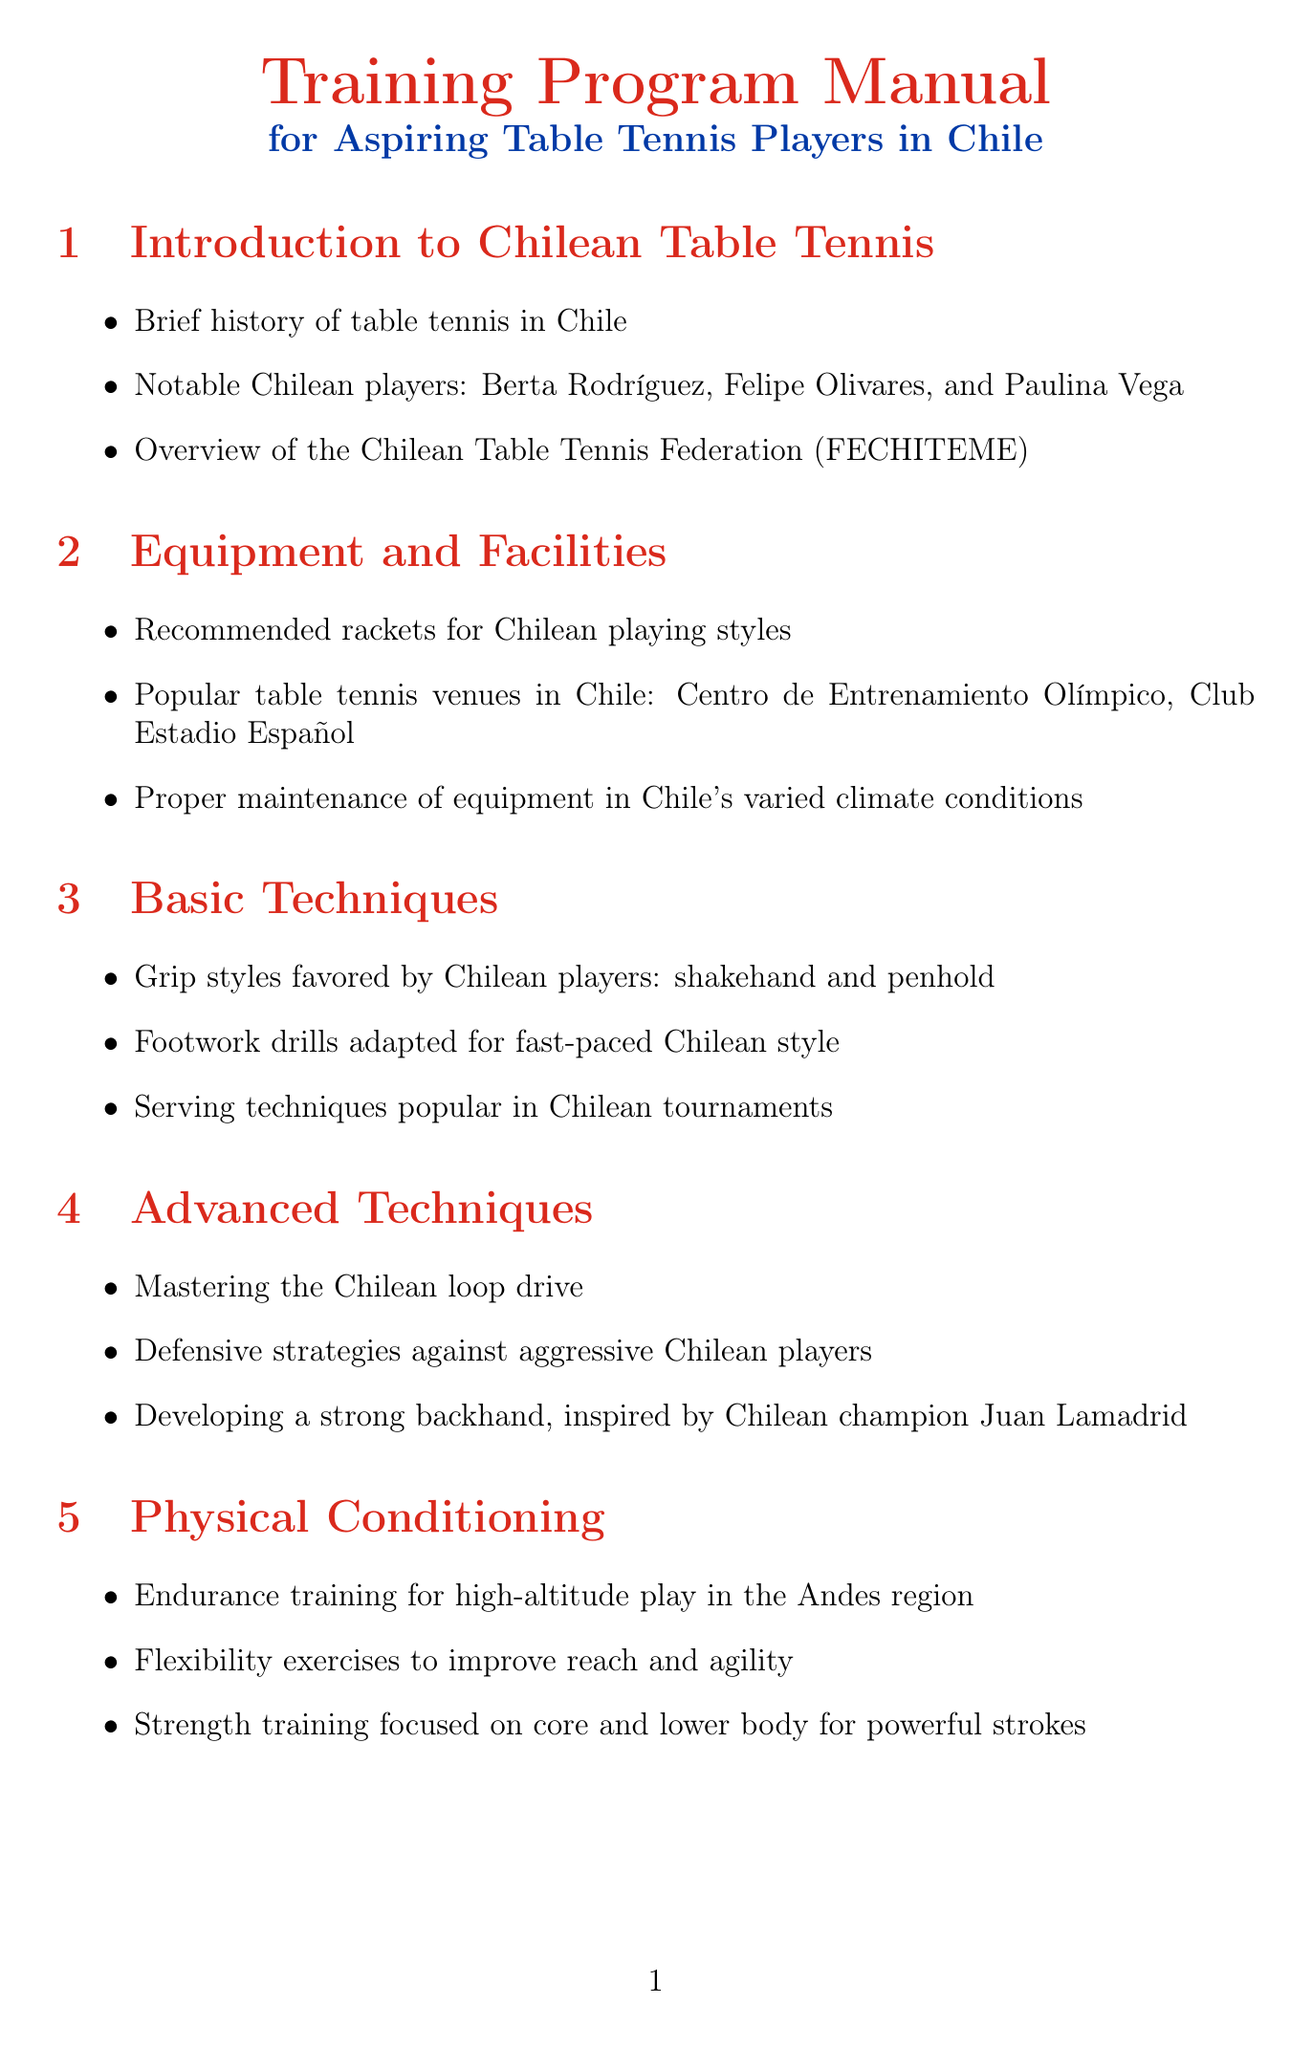What is the title of the manual? The title of the manual is mentioned at the beginning, highlighting its focus on training for table tennis players in Chile.
Answer: Training Program Manual for Aspiring Table Tennis Players in Chile Who are notable Chilean players mentioned in the introduction? The introduction lists notable players who have contributed to table tennis in Chile, specifically naming three individuals.
Answer: Berta Rodríguez, Felipe Olivares, and Paulina Vega What are the recommended grip styles favored by Chilean players? The basic techniques section specifies the types of grip styles that are commonly used by players in Chile.
Answer: shakehand and penhold What is a key physical conditioning exercise for high-altitude play? The physical conditioning section emphasizes the importance of endurance training and mentions its relevance to playing at high altitudes like those in the Andes.
Answer: Endurance training Name one major Chilean tournament discussed in the competition preparation section. The competition preparation section provides an overview of significant tournaments held in Chile for table tennis.
Answer: Campeonato Nacional What is a visualization technique used by the Chilean national team? The mental preparation section describes strategies used by the national team, mentioning a specific technique related to visualization.
Answer: Visualization techniques What types of exercises are included in the practice drills section? The practice drills section enumerates several training exercises, focusing on both multi-ball and partner drills for improving skills.
Answer: Multi-ball training exercises, partner drills What is one pathway to joining the Chilean national team? The career development section outlines different pathways for aspiring players who wish to achieve national team status.
Answer: Pathways to joining the Chilean national team 